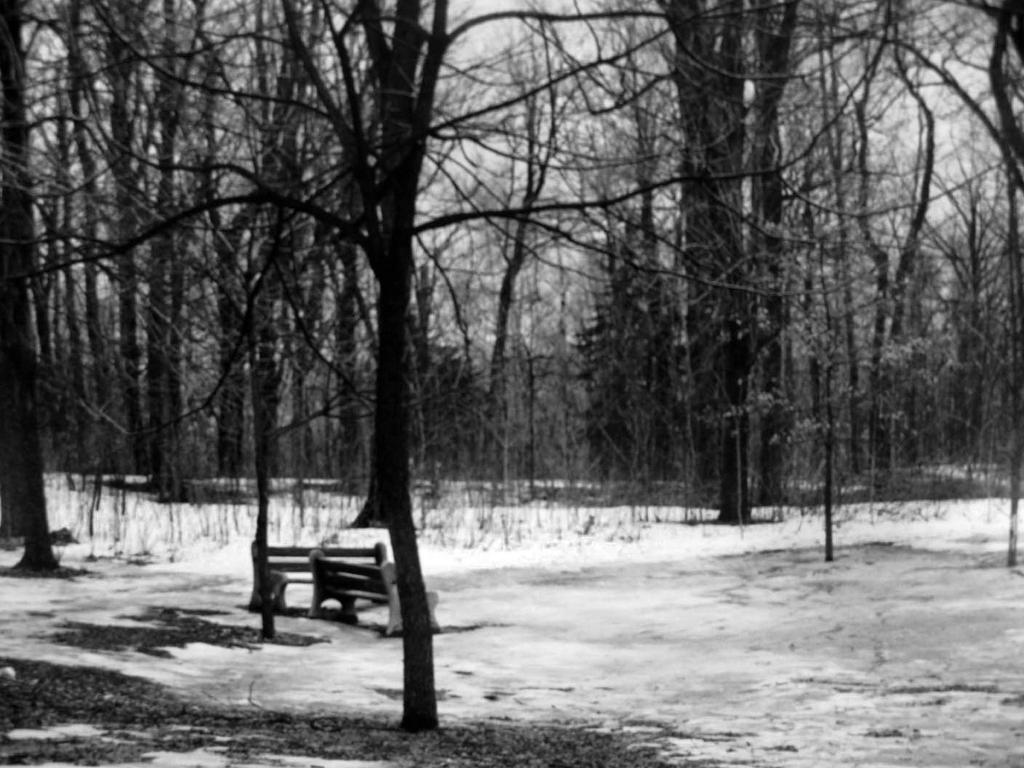How many benches are on the ground in the image? There are two benches on the ground in the image. What else can be seen in the image besides the benches? Trees and the sky are visible in the image. What type of environment might the image depict? The image may have been taken in a forest, given the presence of trees. What type of produce is being harvested in the image? There is no produce or harvesting activity present in the image. 